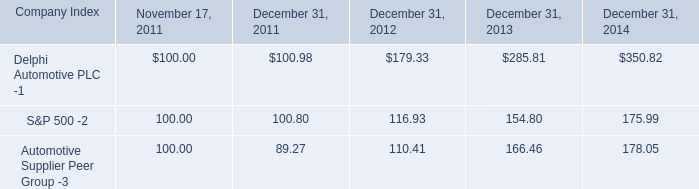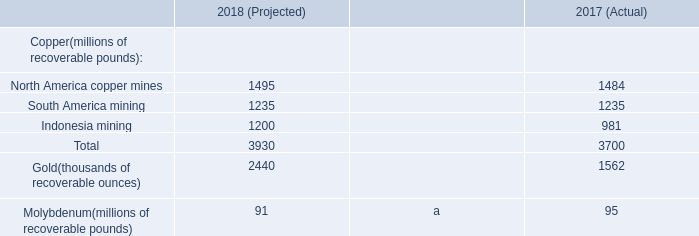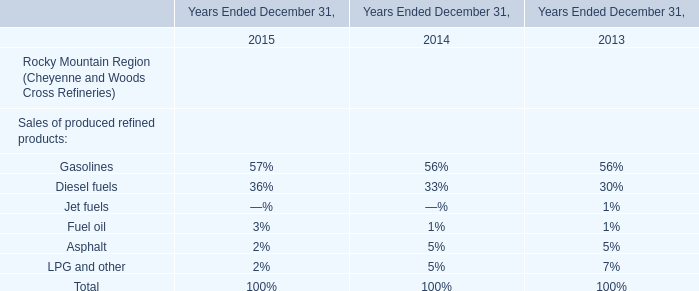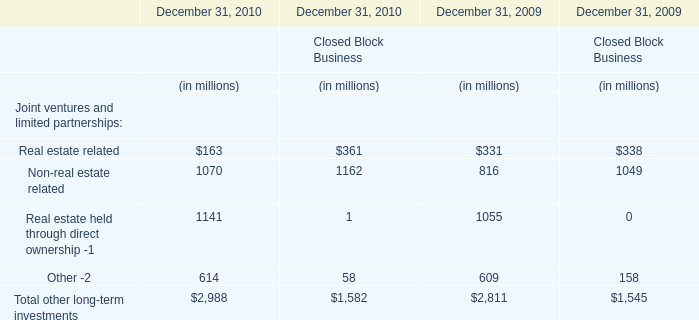What is the percentage of alOther -2 related that are positive to the total amount, in 2010 for Financial Services Businesses 
Computations: (614 / ((((163 + 1070) + 1141) + 614) + 2988))
Answer: 0.10274. 